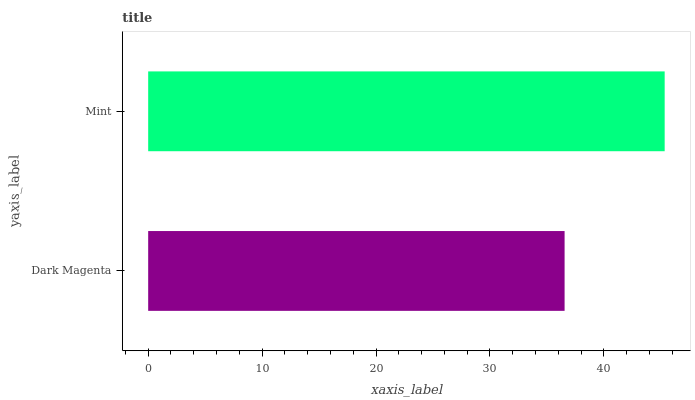Is Dark Magenta the minimum?
Answer yes or no. Yes. Is Mint the maximum?
Answer yes or no. Yes. Is Mint the minimum?
Answer yes or no. No. Is Mint greater than Dark Magenta?
Answer yes or no. Yes. Is Dark Magenta less than Mint?
Answer yes or no. Yes. Is Dark Magenta greater than Mint?
Answer yes or no. No. Is Mint less than Dark Magenta?
Answer yes or no. No. Is Mint the high median?
Answer yes or no. Yes. Is Dark Magenta the low median?
Answer yes or no. Yes. Is Dark Magenta the high median?
Answer yes or no. No. Is Mint the low median?
Answer yes or no. No. 